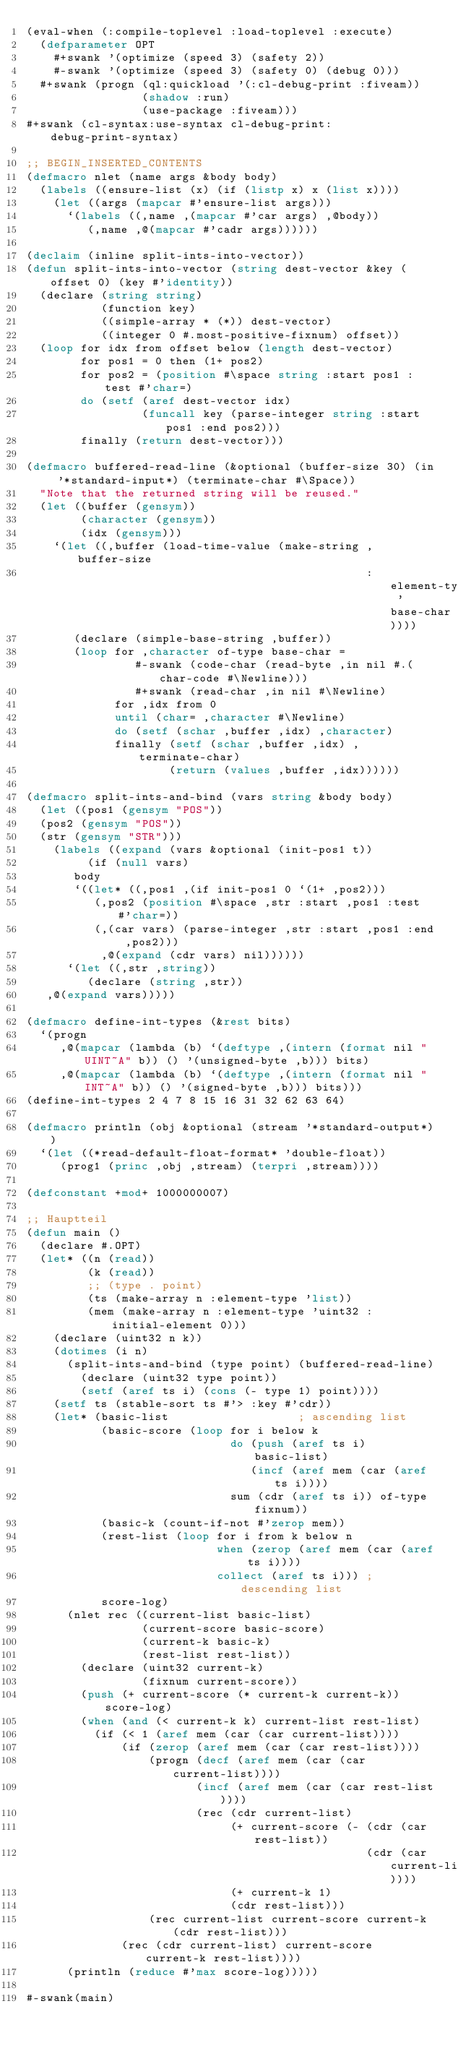Convert code to text. <code><loc_0><loc_0><loc_500><loc_500><_Lisp_>(eval-when (:compile-toplevel :load-toplevel :execute)
  (defparameter OPT
    #+swank '(optimize (speed 3) (safety 2))
    #-swank '(optimize (speed 3) (safety 0) (debug 0)))
  #+swank (progn (ql:quickload '(:cl-debug-print :fiveam))
                 (shadow :run)
                 (use-package :fiveam)))
#+swank (cl-syntax:use-syntax cl-debug-print:debug-print-syntax)

;; BEGIN_INSERTED_CONTENTS
(defmacro nlet (name args &body body)
  (labels ((ensure-list (x) (if (listp x) x (list x))))
    (let ((args (mapcar #'ensure-list args)))
      `(labels ((,name ,(mapcar #'car args) ,@body))
         (,name ,@(mapcar #'cadr args))))))

(declaim (inline split-ints-into-vector))
(defun split-ints-into-vector (string dest-vector &key (offset 0) (key #'identity))
  (declare (string string)
           (function key)
           ((simple-array * (*)) dest-vector)
           ((integer 0 #.most-positive-fixnum) offset))
  (loop for idx from offset below (length dest-vector)
        for pos1 = 0 then (1+ pos2)
        for pos2 = (position #\space string :start pos1 :test #'char=)
        do (setf (aref dest-vector idx)
                 (funcall key (parse-integer string :start pos1 :end pos2)))
        finally (return dest-vector)))

(defmacro buffered-read-line (&optional (buffer-size 30) (in '*standard-input*) (terminate-char #\Space))
  "Note that the returned string will be reused."
  (let ((buffer (gensym))
        (character (gensym))
        (idx (gensym)))
    `(let ((,buffer (load-time-value (make-string ,buffer-size
                                                  :element-type 'base-char))))
       (declare (simple-base-string ,buffer))
       (loop for ,character of-type base-char =
                #-swank (code-char (read-byte ,in nil #.(char-code #\Newline)))
                #+swank (read-char ,in nil #\Newline)
             for ,idx from 0
             until (char= ,character #\Newline)
             do (setf (schar ,buffer ,idx) ,character)
             finally (setf (schar ,buffer ,idx) ,terminate-char)
                     (return (values ,buffer ,idx))))))

(defmacro split-ints-and-bind (vars string &body body)
  (let ((pos1 (gensym "POS"))
	(pos2 (gensym "POS"))
	(str (gensym "STR")))
    (labels ((expand (vars &optional (init-pos1 t))
	       (if (null vars)
		   body
		   `((let* ((,pos1 ,(if init-pos1 0 `(1+ ,pos2)))
			    (,pos2 (position #\space ,str :start ,pos1 :test #'char=))
			    (,(car vars) (parse-integer ,str :start ,pos1 :end ,pos2)))
		       ,@(expand (cdr vars) nil))))))
      `(let ((,str ,string))
         (declare (string ,str))
	 ,@(expand vars)))))

(defmacro define-int-types (&rest bits)
  `(progn
     ,@(mapcar (lambda (b) `(deftype ,(intern (format nil "UINT~A" b)) () '(unsigned-byte ,b))) bits)
     ,@(mapcar (lambda (b) `(deftype ,(intern (format nil "INT~A" b)) () '(signed-byte ,b))) bits)))
(define-int-types 2 4 7 8 15 16 31 32 62 63 64)

(defmacro println (obj &optional (stream '*standard-output*))
  `(let ((*read-default-float-format* 'double-float))
     (prog1 (princ ,obj ,stream) (terpri ,stream))))

(defconstant +mod+ 1000000007)

;; Hauptteil
(defun main ()
  (declare #.OPT)
  (let* ((n (read))
         (k (read))
         ;; (type . point)
         (ts (make-array n :element-type 'list))
         (mem (make-array n :element-type 'uint32 :initial-element 0)))
    (declare (uint32 n k))
    (dotimes (i n)
      (split-ints-and-bind (type point) (buffered-read-line)
        (declare (uint32 type point))
        (setf (aref ts i) (cons (- type 1) point))))
    (setf ts (stable-sort ts #'> :key #'cdr))
    (let* (basic-list                   ; ascending list
           (basic-score (loop for i below k
                              do (push (aref ts i) basic-list)
                                 (incf (aref mem (car (aref ts i))))
                              sum (cdr (aref ts i)) of-type fixnum))
           (basic-k (count-if-not #'zerop mem))
           (rest-list (loop for i from k below n
                            when (zerop (aref mem (car (aref ts i))))
                            collect (aref ts i))) ; descending list
           score-log)
      (nlet rec ((current-list basic-list)
                 (current-score basic-score)
                 (current-k basic-k)
                 (rest-list rest-list))
        (declare (uint32 current-k)
                 (fixnum current-score))
        (push (+ current-score (* current-k current-k)) score-log)
        (when (and (< current-k k) current-list rest-list)
          (if (< 1 (aref mem (car (car current-list))))
              (if (zerop (aref mem (car (car rest-list))))
                  (progn (decf (aref mem (car (car current-list))))
                         (incf (aref mem (car (car rest-list))))
                         (rec (cdr current-list)
                              (+ current-score (- (cdr (car rest-list))
                                                  (cdr (car current-list))))
                              (+ current-k 1)
                              (cdr rest-list)))
                  (rec current-list current-score current-k (cdr rest-list)))
              (rec (cdr current-list) current-score current-k rest-list))))
      (println (reduce #'max score-log)))))

#-swank(main)
</code> 